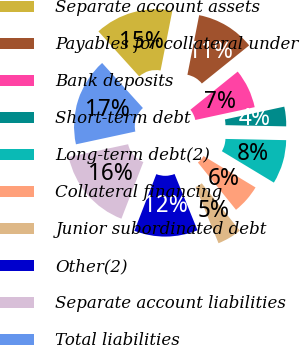<chart> <loc_0><loc_0><loc_500><loc_500><pie_chart><fcel>Separate account assets<fcel>Payables for collateral under<fcel>Bank deposits<fcel>Short-term debt<fcel>Long-term debt(2)<fcel>Collateral financing<fcel>Junior subordinated debt<fcel>Other(2)<fcel>Separate account liabilities<fcel>Total liabilities<nl><fcel>14.81%<fcel>11.11%<fcel>7.41%<fcel>3.7%<fcel>8.33%<fcel>5.56%<fcel>4.63%<fcel>12.04%<fcel>15.74%<fcel>16.67%<nl></chart> 